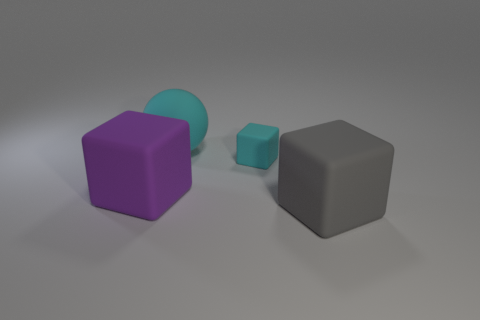Add 1 large rubber balls. How many objects exist? 5 Add 2 large rubber spheres. How many large rubber spheres exist? 3 Subtract all purple cubes. How many cubes are left? 2 Subtract all cyan cubes. How many cubes are left? 2 Subtract 0 gray balls. How many objects are left? 4 Subtract all spheres. How many objects are left? 3 Subtract 1 balls. How many balls are left? 0 Subtract all gray blocks. Subtract all yellow spheres. How many blocks are left? 2 Subtract all yellow cylinders. How many brown balls are left? 0 Subtract all blue metal balls. Subtract all cyan blocks. How many objects are left? 3 